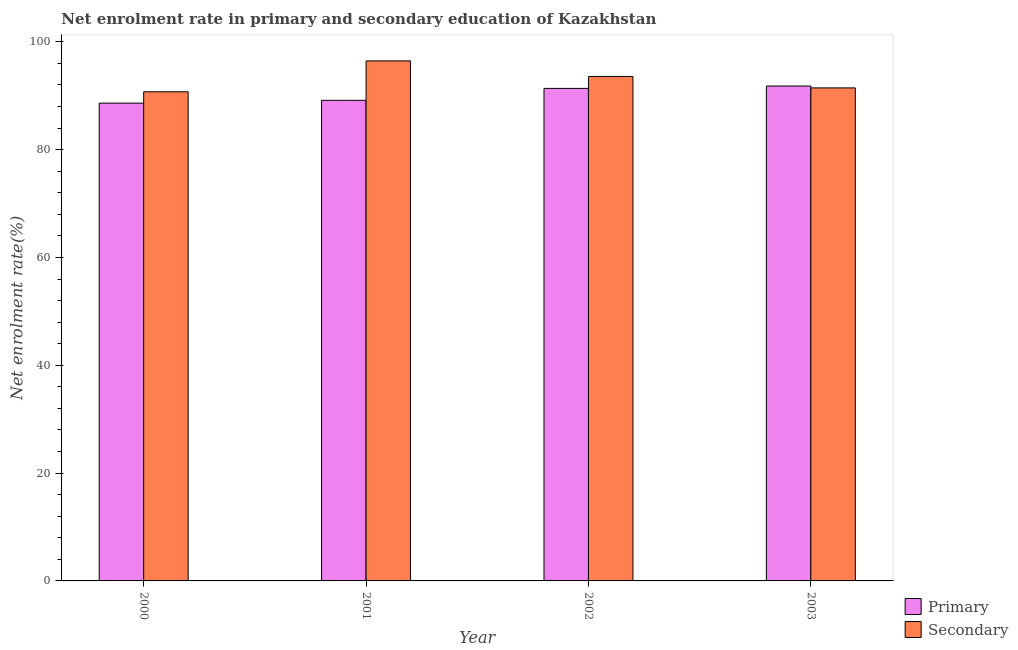Are the number of bars on each tick of the X-axis equal?
Provide a succinct answer. Yes. What is the enrollment rate in primary education in 2003?
Offer a terse response. 91.81. Across all years, what is the maximum enrollment rate in primary education?
Offer a very short reply. 91.81. Across all years, what is the minimum enrollment rate in primary education?
Provide a succinct answer. 88.63. In which year was the enrollment rate in primary education maximum?
Your answer should be very brief. 2003. What is the total enrollment rate in secondary education in the graph?
Give a very brief answer. 372.25. What is the difference between the enrollment rate in secondary education in 2000 and that in 2002?
Provide a short and direct response. -2.84. What is the difference between the enrollment rate in primary education in 2000 and the enrollment rate in secondary education in 2003?
Provide a succinct answer. -3.17. What is the average enrollment rate in secondary education per year?
Offer a terse response. 93.06. In the year 2002, what is the difference between the enrollment rate in secondary education and enrollment rate in primary education?
Provide a succinct answer. 0. What is the ratio of the enrollment rate in primary education in 2000 to that in 2002?
Provide a short and direct response. 0.97. Is the difference between the enrollment rate in primary education in 2001 and 2002 greater than the difference between the enrollment rate in secondary education in 2001 and 2002?
Ensure brevity in your answer.  No. What is the difference between the highest and the second highest enrollment rate in primary education?
Ensure brevity in your answer.  0.44. What is the difference between the highest and the lowest enrollment rate in secondary education?
Ensure brevity in your answer.  5.73. What does the 1st bar from the left in 2002 represents?
Provide a succinct answer. Primary. What does the 1st bar from the right in 2001 represents?
Your answer should be very brief. Secondary. How many bars are there?
Offer a very short reply. 8. What is the difference between two consecutive major ticks on the Y-axis?
Make the answer very short. 20. Are the values on the major ticks of Y-axis written in scientific E-notation?
Provide a short and direct response. No. Where does the legend appear in the graph?
Offer a very short reply. Bottom right. How are the legend labels stacked?
Your answer should be compact. Vertical. What is the title of the graph?
Keep it short and to the point. Net enrolment rate in primary and secondary education of Kazakhstan. What is the label or title of the Y-axis?
Your response must be concise. Net enrolment rate(%). What is the Net enrolment rate(%) in Primary in 2000?
Your response must be concise. 88.63. What is the Net enrolment rate(%) of Secondary in 2000?
Keep it short and to the point. 90.74. What is the Net enrolment rate(%) of Primary in 2001?
Provide a short and direct response. 89.15. What is the Net enrolment rate(%) in Secondary in 2001?
Your answer should be compact. 96.47. What is the Net enrolment rate(%) in Primary in 2002?
Give a very brief answer. 91.36. What is the Net enrolment rate(%) in Secondary in 2002?
Provide a succinct answer. 93.58. What is the Net enrolment rate(%) in Primary in 2003?
Offer a terse response. 91.81. What is the Net enrolment rate(%) in Secondary in 2003?
Provide a succinct answer. 91.46. Across all years, what is the maximum Net enrolment rate(%) of Primary?
Provide a succinct answer. 91.81. Across all years, what is the maximum Net enrolment rate(%) of Secondary?
Make the answer very short. 96.47. Across all years, what is the minimum Net enrolment rate(%) in Primary?
Your answer should be very brief. 88.63. Across all years, what is the minimum Net enrolment rate(%) of Secondary?
Keep it short and to the point. 90.74. What is the total Net enrolment rate(%) in Primary in the graph?
Your response must be concise. 360.95. What is the total Net enrolment rate(%) of Secondary in the graph?
Your answer should be compact. 372.25. What is the difference between the Net enrolment rate(%) in Primary in 2000 and that in 2001?
Provide a short and direct response. -0.52. What is the difference between the Net enrolment rate(%) in Secondary in 2000 and that in 2001?
Your response must be concise. -5.73. What is the difference between the Net enrolment rate(%) in Primary in 2000 and that in 2002?
Make the answer very short. -2.73. What is the difference between the Net enrolment rate(%) in Secondary in 2000 and that in 2002?
Provide a short and direct response. -2.84. What is the difference between the Net enrolment rate(%) of Primary in 2000 and that in 2003?
Ensure brevity in your answer.  -3.17. What is the difference between the Net enrolment rate(%) of Secondary in 2000 and that in 2003?
Provide a short and direct response. -0.72. What is the difference between the Net enrolment rate(%) of Primary in 2001 and that in 2002?
Keep it short and to the point. -2.21. What is the difference between the Net enrolment rate(%) in Secondary in 2001 and that in 2002?
Your response must be concise. 2.89. What is the difference between the Net enrolment rate(%) in Primary in 2001 and that in 2003?
Your answer should be very brief. -2.65. What is the difference between the Net enrolment rate(%) of Secondary in 2001 and that in 2003?
Your answer should be very brief. 5.01. What is the difference between the Net enrolment rate(%) of Primary in 2002 and that in 2003?
Offer a very short reply. -0.44. What is the difference between the Net enrolment rate(%) in Secondary in 2002 and that in 2003?
Your response must be concise. 2.12. What is the difference between the Net enrolment rate(%) in Primary in 2000 and the Net enrolment rate(%) in Secondary in 2001?
Your answer should be compact. -7.84. What is the difference between the Net enrolment rate(%) of Primary in 2000 and the Net enrolment rate(%) of Secondary in 2002?
Provide a short and direct response. -4.95. What is the difference between the Net enrolment rate(%) of Primary in 2000 and the Net enrolment rate(%) of Secondary in 2003?
Offer a very short reply. -2.83. What is the difference between the Net enrolment rate(%) in Primary in 2001 and the Net enrolment rate(%) in Secondary in 2002?
Your answer should be very brief. -4.43. What is the difference between the Net enrolment rate(%) in Primary in 2001 and the Net enrolment rate(%) in Secondary in 2003?
Your answer should be compact. -2.31. What is the difference between the Net enrolment rate(%) of Primary in 2002 and the Net enrolment rate(%) of Secondary in 2003?
Your answer should be compact. -0.09. What is the average Net enrolment rate(%) of Primary per year?
Your answer should be compact. 90.24. What is the average Net enrolment rate(%) in Secondary per year?
Ensure brevity in your answer.  93.06. In the year 2000, what is the difference between the Net enrolment rate(%) in Primary and Net enrolment rate(%) in Secondary?
Provide a short and direct response. -2.11. In the year 2001, what is the difference between the Net enrolment rate(%) in Primary and Net enrolment rate(%) in Secondary?
Your answer should be very brief. -7.32. In the year 2002, what is the difference between the Net enrolment rate(%) in Primary and Net enrolment rate(%) in Secondary?
Give a very brief answer. -2.22. In the year 2003, what is the difference between the Net enrolment rate(%) in Primary and Net enrolment rate(%) in Secondary?
Keep it short and to the point. 0.35. What is the ratio of the Net enrolment rate(%) of Secondary in 2000 to that in 2001?
Your answer should be very brief. 0.94. What is the ratio of the Net enrolment rate(%) in Primary in 2000 to that in 2002?
Provide a short and direct response. 0.97. What is the ratio of the Net enrolment rate(%) of Secondary in 2000 to that in 2002?
Provide a short and direct response. 0.97. What is the ratio of the Net enrolment rate(%) in Primary in 2000 to that in 2003?
Make the answer very short. 0.97. What is the ratio of the Net enrolment rate(%) in Primary in 2001 to that in 2002?
Your answer should be very brief. 0.98. What is the ratio of the Net enrolment rate(%) of Secondary in 2001 to that in 2002?
Your answer should be very brief. 1.03. What is the ratio of the Net enrolment rate(%) in Primary in 2001 to that in 2003?
Offer a terse response. 0.97. What is the ratio of the Net enrolment rate(%) in Secondary in 2001 to that in 2003?
Provide a succinct answer. 1.05. What is the ratio of the Net enrolment rate(%) in Secondary in 2002 to that in 2003?
Your response must be concise. 1.02. What is the difference between the highest and the second highest Net enrolment rate(%) in Primary?
Provide a succinct answer. 0.44. What is the difference between the highest and the second highest Net enrolment rate(%) of Secondary?
Your answer should be very brief. 2.89. What is the difference between the highest and the lowest Net enrolment rate(%) of Primary?
Your answer should be very brief. 3.17. What is the difference between the highest and the lowest Net enrolment rate(%) of Secondary?
Ensure brevity in your answer.  5.73. 